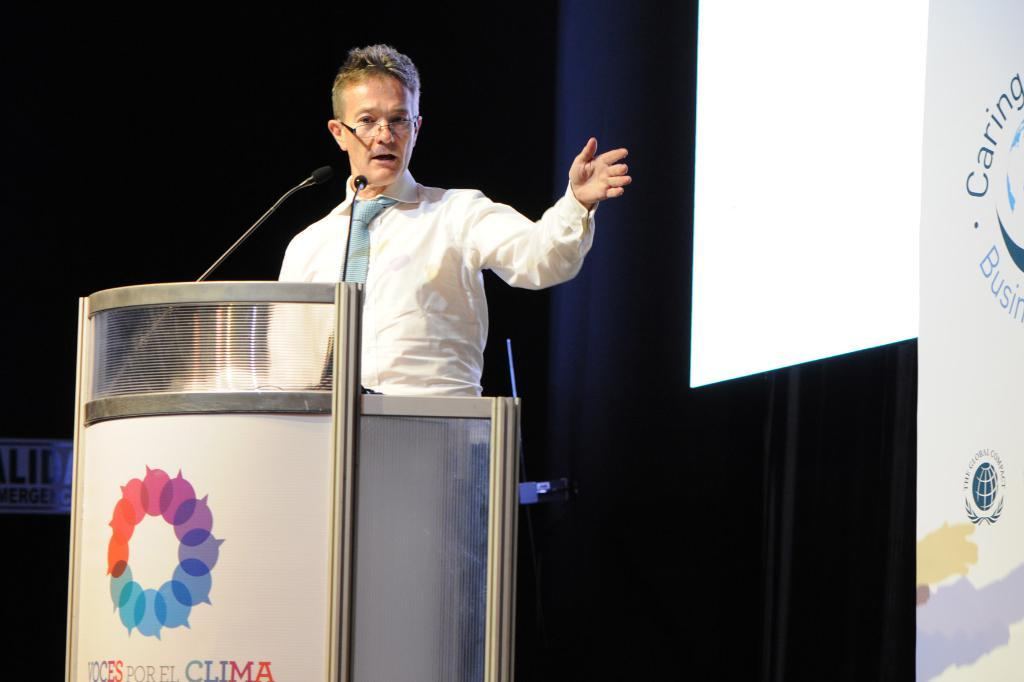<image>
Provide a brief description of the given image. a man standing at a podium reading Por El Clima 